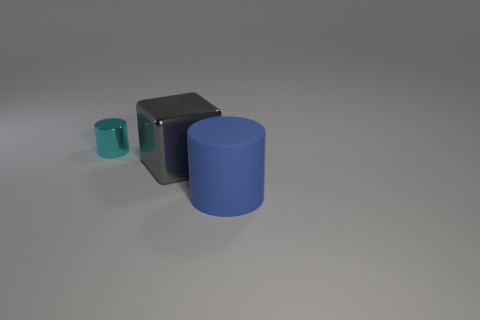The tiny cylinder has what color? The small cylinder in the image exhibits a refreshing cyan hue, reminiscent of a serene oceanic palette. 